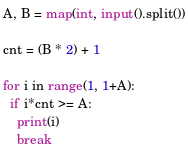Convert code to text. <code><loc_0><loc_0><loc_500><loc_500><_Python_>A, B = map(int, input().split())

cnt = (B * 2) + 1

for i in range(1, 1+A):
  if i*cnt >= A:
    print(i)
    break
    </code> 